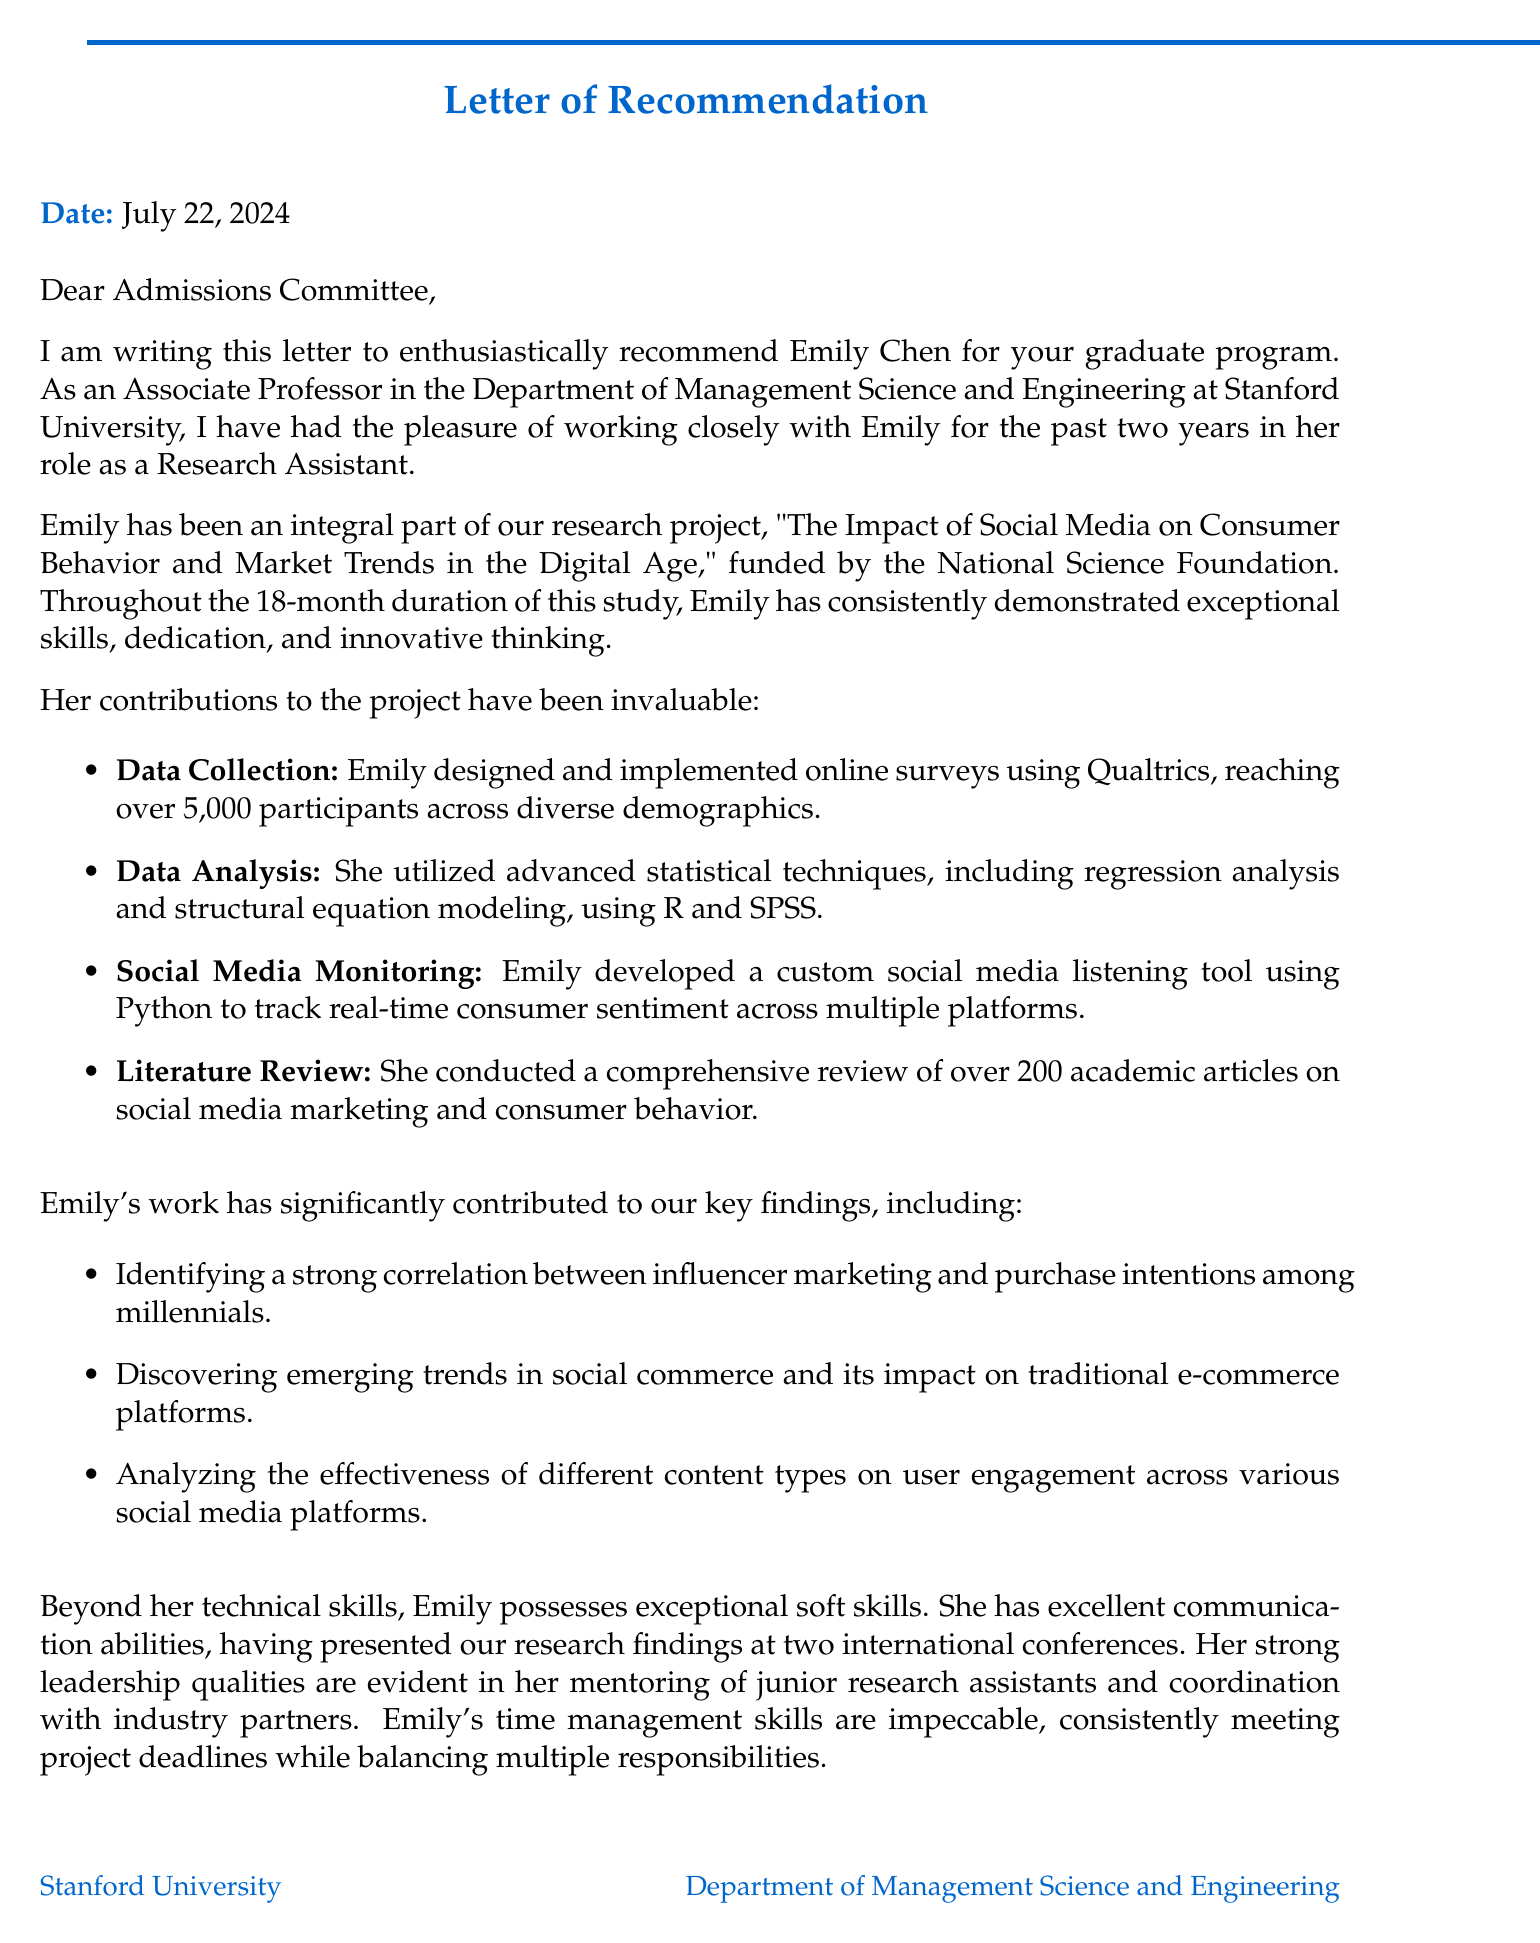What is the name of the applicant? The applicant's name is mentioned at the beginning of the document as Emily Chen.
Answer: Emily Chen Who is the recommender? The letter includes the name and title of the recommender, which is Dr. Sarah Johnson.
Answer: Dr. Sarah Johnson What is the title of the research project? The letter states the title of the research project being discussed as "The Impact of Social Media on Consumer Behavior and Market Trends in the Digital Age."
Answer: The Impact of Social Media on Consumer Behavior and Market Trends in the Digital Age How long did the research project last? The duration of the research project is specified in the document as 18 months.
Answer: 18 months What funding source supported the project? The document mentions that the project was funded by the National Science Foundation (NSF).
Answer: National Science Foundation (NSF) What was one key finding related to influencer marketing? A specific key finding noted in the document is the correlation between influencer marketing and purchase intentions among millennials.
Answer: Strong correlation between influencer marketing and purchase intentions among millennials What soft skill does Emily possess that helped her coordinate with industry partners? The document highlights her strong leadership abilities as a critical soft skill for coordinating with partners.
Answer: Strong leadership abilities What award did Emily receive from her department? The document mentions she received the 'Outstanding Research Assistant Award' from her department.
Answer: Outstanding Research Assistant Award What is the overall recommendation given by the recommender? The letter concludes with the recommender providing a strong recommendation for Emily in the clearest terms.
Answer: Highest recommendation without reservation 